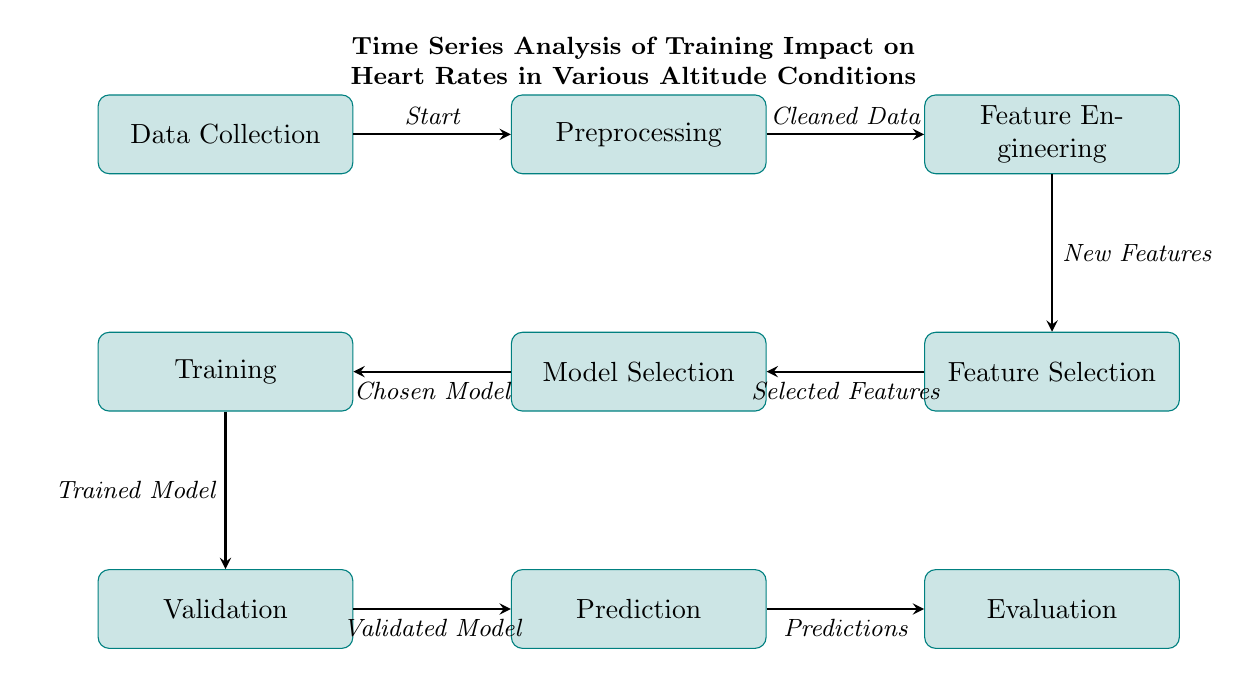What is the first step in the process? The first node in the diagram is labeled "Data Collection," indicating that this is the starting point of the process.
Answer: Data Collection How many nodes are in the diagram? By counting each distinct rectangular node in the diagram, we see there are eight nodes in total.
Answer: Eight What does the "Preprocessing" step yield? The arrow indicates that the outcome of the Preprocessing step leads to "Cleaned Data," which is the next node in the sequence.
Answer: Cleaned Data Which step comes just before "Prediction"? The diagram shows that "Validation" is the node that flows into "Prediction," thus it precedes it.
Answer: Validation What type of analysis is being depicted in the title of the diagram? The title clearly states that it is a "Time Series Analysis," describing the overall analysis context of the training impact.
Answer: Time Series Analysis What is the last step indicated in the diagram? The final node in the sequence, which the flow points to, is "Evaluation," signifying it as the last stage of the process.
Answer: Evaluation What is the output of the "Prediction" step? The diagram specifies that "Predictions" is the outcome of the Prediction step, rendering it the output of that stage.
Answer: Predictions Which node represents the stage where features are chosen? The diagram has a node labeled "Feature Selection" which is where selected features are indicated as chosen from the preceding step.
Answer: Feature Selection What is the relationship between "Feature Engineering" and "Feature Selection"? The arrow connects "Feature Engineering" to "Feature Selection," indicating that the newly created features from the former lead into the selection process in the latter.
Answer: Selected Features 